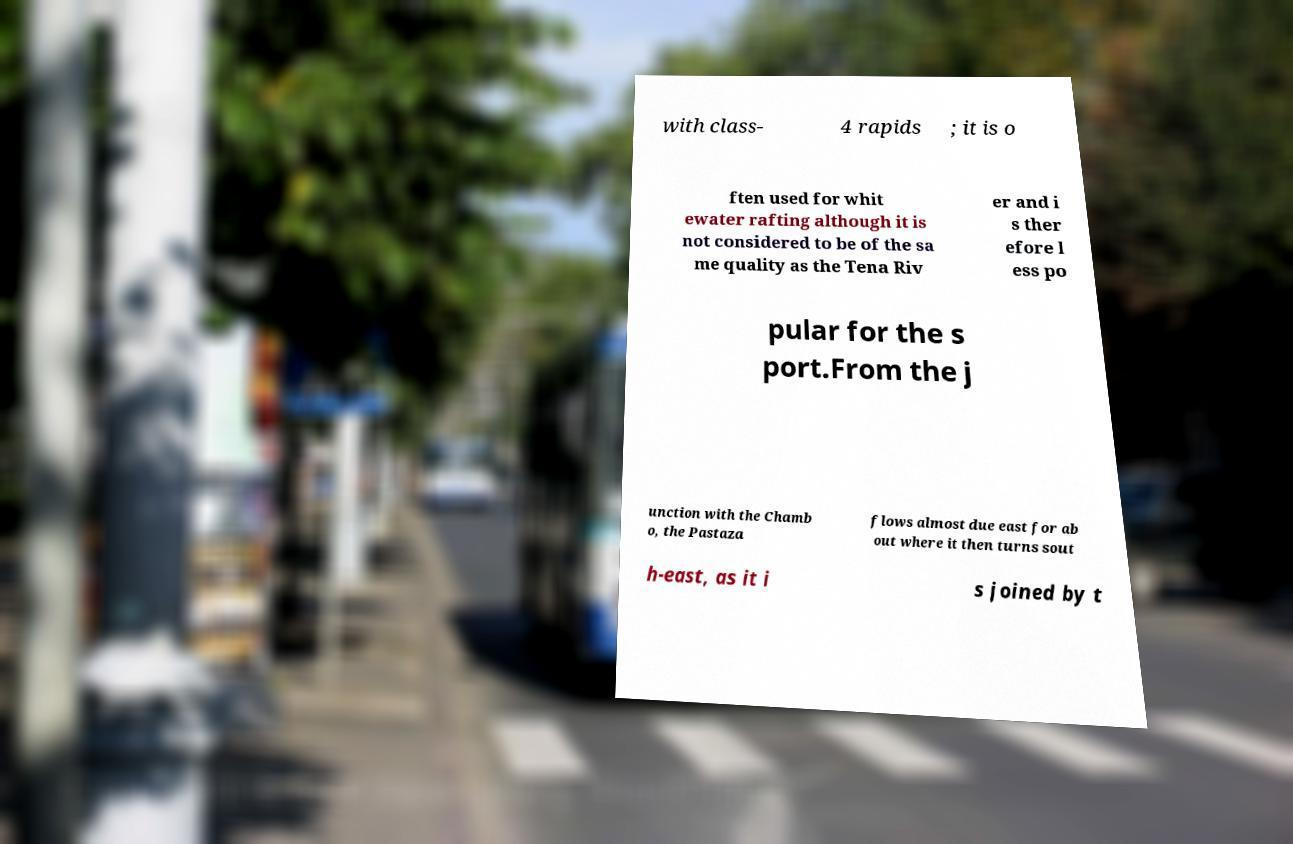There's text embedded in this image that I need extracted. Can you transcribe it verbatim? with class- 4 rapids ; it is o ften used for whit ewater rafting although it is not considered to be of the sa me quality as the Tena Riv er and i s ther efore l ess po pular for the s port.From the j unction with the Chamb o, the Pastaza flows almost due east for ab out where it then turns sout h-east, as it i s joined by t 